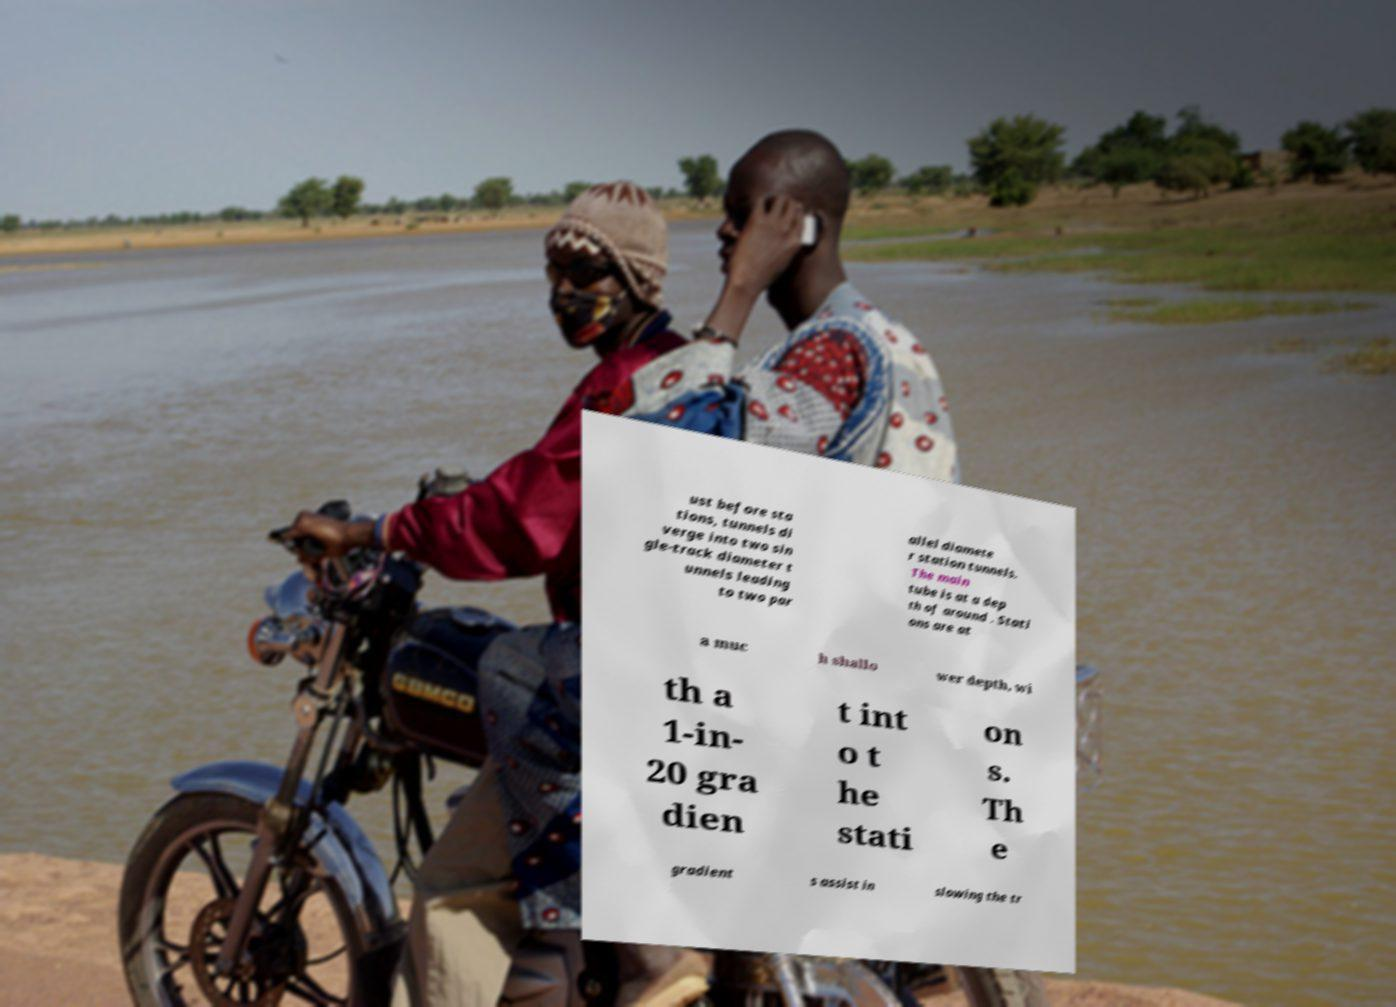Can you accurately transcribe the text from the provided image for me? ust before sta tions, tunnels di verge into two sin gle-track diameter t unnels leading to two par allel diamete r station tunnels. The main tube is at a dep th of around . Stati ons are at a muc h shallo wer depth, wi th a 1-in- 20 gra dien t int o t he stati on s. Th e gradient s assist in slowing the tr 